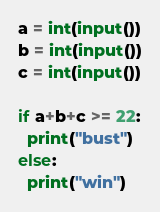Convert code to text. <code><loc_0><loc_0><loc_500><loc_500><_Python_>a = int(input())
b = int(input())
c = int(input())

if a+b+c >= 22:
  print("bust")
else:
  print("win")</code> 